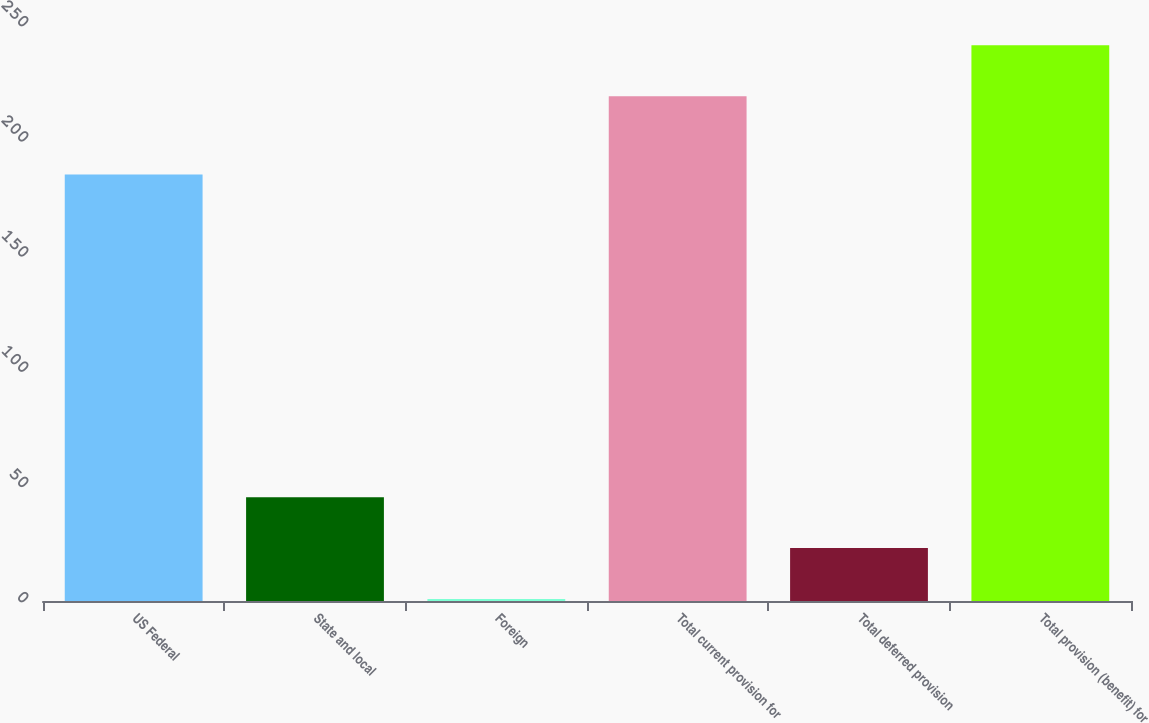Convert chart to OTSL. <chart><loc_0><loc_0><loc_500><loc_500><bar_chart><fcel>US Federal<fcel>State and local<fcel>Foreign<fcel>Total current provision for<fcel>Total deferred provision<fcel>Total provision (benefit) for<nl><fcel>185.1<fcel>45.06<fcel>0.9<fcel>219.1<fcel>22.98<fcel>241.18<nl></chart> 